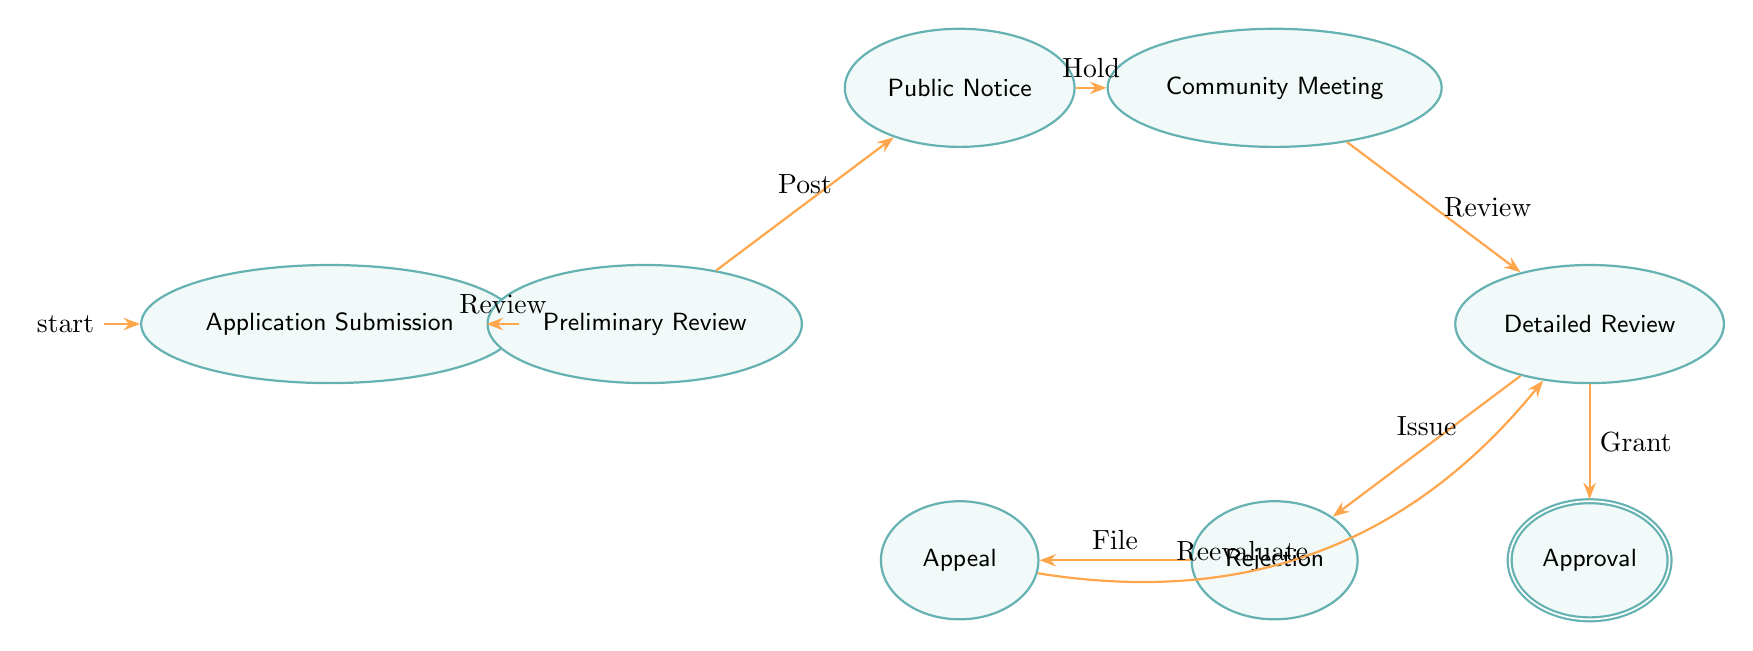What is the initial state of the workflow? The diagram defines the initial state with the symbol "Initial" next to the node, which indicates that this is where the process begins. The initial state is "Application Submission."
Answer: Application Submission How many states are in the diagram? The diagram displays a total of eight distinct states, which can be counted from the state nodes displayed in the figure.
Answer: Eight Which state comes after Preliminary Review? By following the directed edge (arrow) from the "Preliminary Review" state, the next state reached is "Public Notice."
Answer: Public Notice What are the two possible outcomes from the Detailed Review state? The diagram shows two outgoing arrows from the "Detailed Review" node, leading to "Approval" and "Rejection," which represent the two possible outcomes of that state.
Answer: Approval and Rejection What transition leads to the Appeal state? The diagram shows an arrow pointing from the "Rejection" state to the "Appeal" state, specifying the action "File," which leads to this transition.
Answer: File What state must be completed before conducting the Detailed Review? The diagram indicates that the "Community Meeting" must occur first, as there is a directed transition from "Community Meeting" to "Detailed Review."
Answer: Community Meeting How does one move from the Appeal state back into the main workflow? The "Appeal" state has an outgoing transition named "Reevaluate," which directs back into the "Detailed Review" state, showing the flow of the process.
Answer: Reevaluate What is the final state that represents approval? The diagram characterizes the terminal successful outcome state as "Approval," indicated with the accepting state symbol.
Answer: Approval 